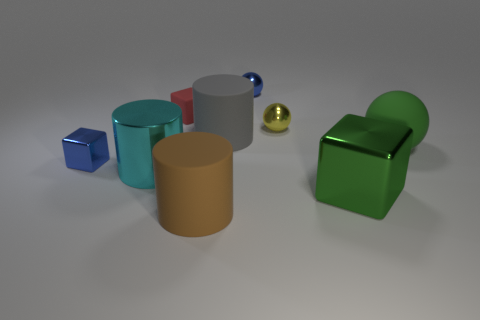Add 1 gray objects. How many objects exist? 10 Subtract all spheres. How many objects are left? 6 Subtract all large red matte balls. Subtract all green matte balls. How many objects are left? 8 Add 7 tiny rubber things. How many tiny rubber things are left? 8 Add 5 large cylinders. How many large cylinders exist? 8 Subtract 0 purple spheres. How many objects are left? 9 